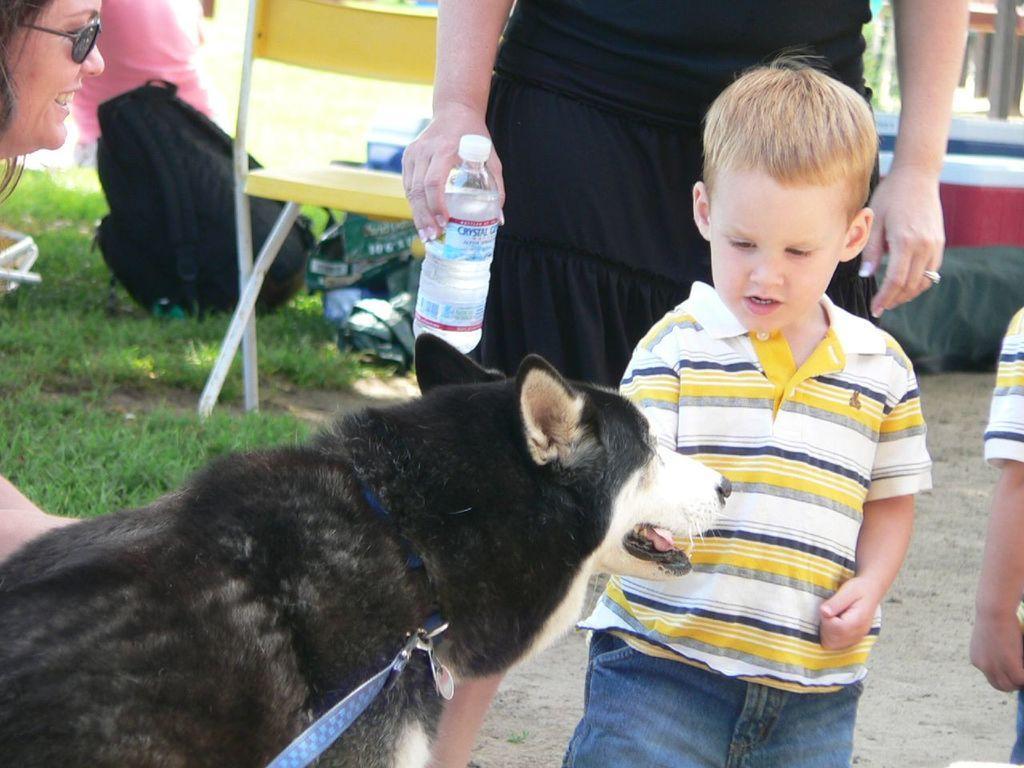In one or two sentences, can you explain what this image depicts? In this picture we can see a woman wore goggles, smiling and in front of a dog we can see some people and a person holding a bottle and in the background we can see the grass, chair, bag and some objects. 